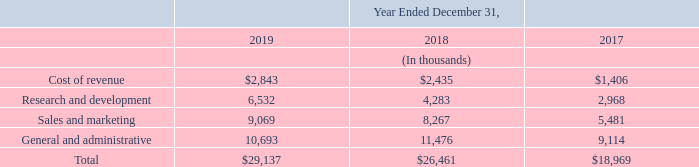The Company recognizes these compensation costs on a straight-line basis over the requisite service period of the award, which is generally the award vesting term of four years. Forfeitures are accounted for as they occur.
Total stock-based compensation cost capitalized in inventory was less than $0.8 million in the years ended December 31, 2019, 2018 and 2017.
As of December 31, 2019, $7.8 million of unrecognized compensation cost related to stock options is expected to be recognized over a weighted-average period of 2.1 years and $41.3 million of unrecognized compensation cost related to unvested RSUs is expected to be recognized over a weighted-average period of 2.2 years. If there are any modifications or cancellations of the underlying unvested awards, the Company may be required to accelerate, increase or cancel all or a portion of the remaining unearned stock-based compensation expense.
The  following  table  sets  forth  the  stock-based  compensation  expense  resulting  from  stock  options,  RSUs,  and  the  ESPP  included  in  the  Company’s consolidated statements of operations:
Which years was the total stock-based compensation cost capitalized in inventory less than $0.8 million? 2019, 2018 and 2017. What was the research and development expense in 2019?
Answer scale should be: thousand. 6,532. What was the percentage change in cost of revenue from 2018 to 2019?
Answer scale should be: percent. ($2,843 - $2,435)/$2,435 
Answer: 16.76. Which year has the highest general and administrative expense? 11,476 > 10,693 >  9,114 
Answer: 2018. What was the change in sales and marketing expenses from 2017 to 2018?
Answer scale should be: thousand. 8,267 -  5,481 
Answer: 2786. What may be required of the company if there are any modifications or cancellations of the underlying unvested awards? May be required to accelerate, increase or cancel all or a portion of the remaining unearned stock-based compensation expense. 